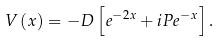Convert formula to latex. <formula><loc_0><loc_0><loc_500><loc_500>V \left ( x \right ) = - D \left [ e ^ { - 2 x } + i P e ^ { - x } \right ] .</formula> 